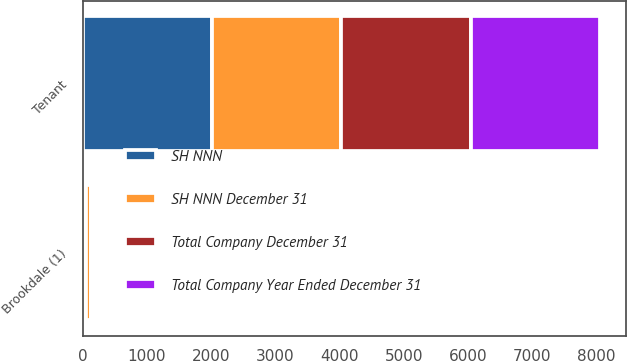Convert chart to OTSL. <chart><loc_0><loc_0><loc_500><loc_500><stacked_bar_chart><ecel><fcel>Tenant<fcel>Brookdale (1)<nl><fcel>Total Company December 31<fcel>2016<fcel>17<nl><fcel>SH NNN December 31<fcel>2016<fcel>69<nl><fcel>Total Company Year Ended December 31<fcel>2016<fcel>12<nl><fcel>SH NNN<fcel>2016<fcel>59<nl></chart> 